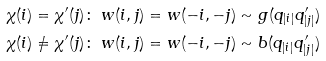Convert formula to latex. <formula><loc_0><loc_0><loc_500><loc_500>\chi ( i ) = \chi ^ { \prime } ( j ) & \colon \ w ( i , j ) = w ( - i , - j ) \sim g ( q _ { | i | } q ^ { \prime } _ { | j | } ) \\ \chi ( i ) \ne \chi ^ { \prime } ( j ) & \colon \ w ( i , j ) = w ( - i , - j ) \sim b ( q _ { | i | } q ^ { \prime } _ { | j | } )</formula> 